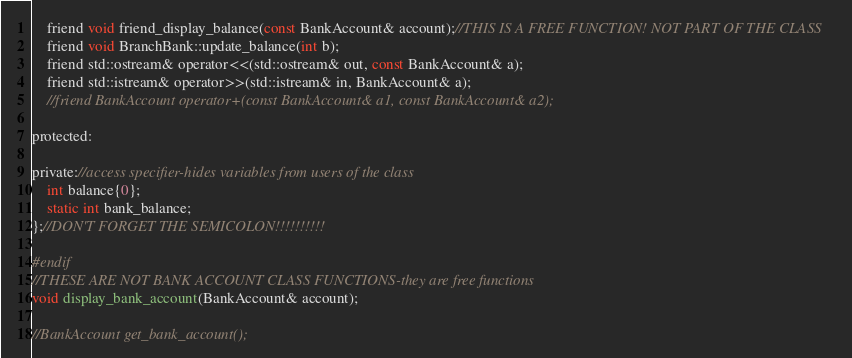<code> <loc_0><loc_0><loc_500><loc_500><_C_>    friend void friend_display_balance(const BankAccount& account);//THIS IS A FREE FUNCTION! NOT PART OF THE CLASS
    friend void BranchBank::update_balance(int b);
    friend std::ostream& operator<<(std::ostream& out, const BankAccount& a);
    friend std::istream& operator>>(std::istream& in, BankAccount& a);
    //friend BankAccount operator+(const BankAccount& a1, const BankAccount& a2);

protected:
    
private://access specifier-hides variables from users of the class
    int balance{0};    
    static int bank_balance;
};//DON'T FORGET THE SEMICOLON!!!!!!!!!!

#endif
//THESE ARE NOT BANK ACCOUNT CLASS FUNCTIONS-they are free functions
void display_bank_account(BankAccount& account);

//BankAccount get_bank_account();</code> 